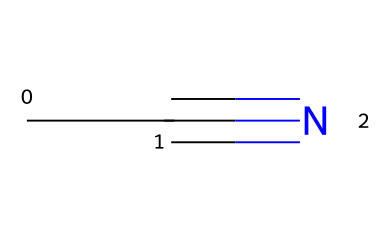What is the name of this chemical? The SMILES representation 'CC#N' indicates a carbon chain with a triple bond to a nitrogen atom. This structure corresponds to acetonitrile, which is a common nitrile compound.
Answer: acetonitrile How many carbon atoms are in acetonitrile? Looking at the SMILES string 'CC#N', there are two 'C' characters, indicating that there are two carbon atoms in acetonitrile.
Answer: 2 What type of bond exists between the carbon and nitrogen atoms in acetonitrile? The presence of the '#' symbol in the SMILES 'CC#N' signifies a triple bond between the final carbon and nitrogen atom in this molecular structure.
Answer: triple bond What is the total number of hydrogen atoms in acetonitrile? Each carbon in this nitrile can bond with three hydrogen atoms; however, since one carbon is triple bonded to nitrogen, it can only bond with one hydrogen. Thus, the total is one hydrogen atom for the terminal carbon and two from the other carbon, making it three hydrogen atoms in total.
Answer: 3 What type of compound is acetonitrile classified as? The presence of a nitrile functional group, indicated by the triple bond between carbon and nitrogen, shows that acetonitrile is classified as a nitrile compound.
Answer: nitrile Why is acetonitrile considered a polar solvent? The difference in electronegativity between the carbon and nitrogen atoms creates a polar bond. This results in a dipole moment, making acetonitrile a polar solvent useful in various applications including electronic cleaning.
Answer: polar solvent 